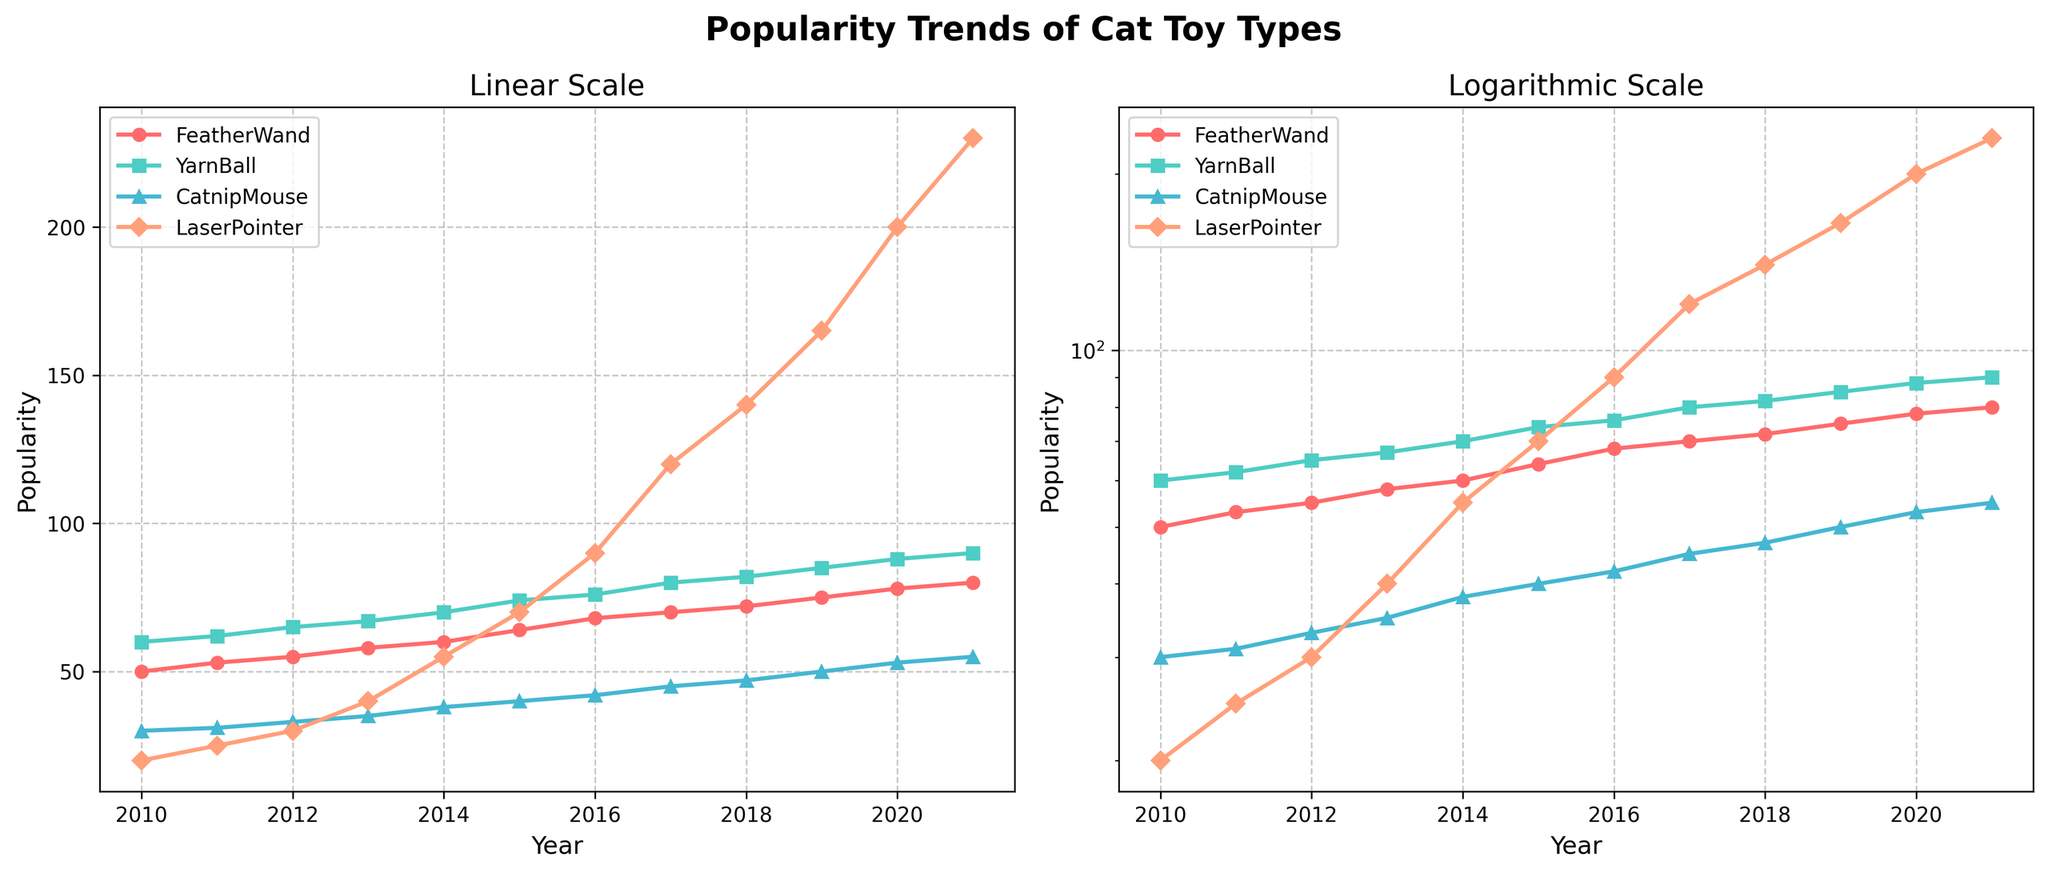What's the title of the figure? The title of the figure appears on top of the plot. It says "Popularity Trends of Cat Toy Types".
Answer: Popularity Trends of Cat Toy Types What are the labels on the x-axis and y-axis? The x-axis and y-axis labels can be found near the bottom and the side of each subplot. The x-axis is labeled "Year", and the y-axis is labeled "Popularity".
Answer: Year and Popularity Which toy type has the highest popularity in 2021? To find the highest popularity in 2021, look for the highest point in the 2021 column of y-values in both plots. The LaserPointer toy has the highest y-value among the four toy types.
Answer: LaserPointer In which year did the popularity of the FeatherWand first reach 60? Look for the FeatherWand data line and identify the point where it first reaches 60 on the y-axis in both subplots. This happens in the year 2014.
Answer: 2014 Compare the popularity trend of the YarnBall to the CatnipMouse. Which toy type saw a steeper increase over time? Comparing the slopes of both YarnBall and CatnipMouse lines from 2010 to 2021 in both plots, the YarnBall shows a relatively steeper increase in popularity.
Answer: YarnBall What is the popularity of the LaserPointer toy in 2015 in the logarithmic scale subplot? Locate the LaserPointer line in the logarithmic scale subplot and find the corresponding y-value for the year 2015. The value is close to 70.
Answer: 70 How did the popularity of the CatnipMouse change between 2010 and 2015? Check the values in both plots. The CatnipMouse increased from 30 in 2010 to 40 in 2015, indicating a steady increase.
Answer: Increased from 30 to 40 Which toy type showed the least change from 2010 to 2021? By comparing the ranges of changes in both plots, FeatherWand shows the least change, starting from 50 to ending at 80.
Answer: FeatherWand In the logarithmic scale subplot, which toy type’s growth rate appears the most exponential? An exponential growth appears as a straight line in the log plot. The LaserPointer’s line is the closest to a straight line, indicating the most exponential growth rate.
Answer: LaserPointer Considering both plots, which toy type appears to have a consistent line with no significant fluctuations? By examining the smoothness of the lines in both subplots, YarnBall shows a consistent and smooth increase without significant fluctuations.
Answer: YarnBall 